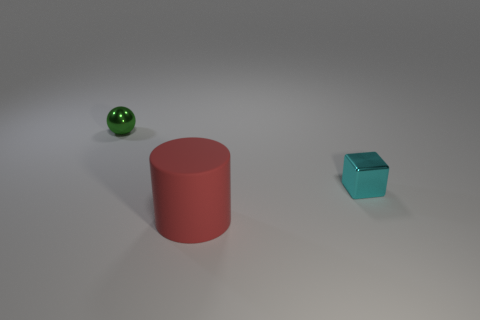Add 2 tiny green spheres. How many objects exist? 5 Subtract all cylinders. How many objects are left? 2 Subtract 1 red cylinders. How many objects are left? 2 Subtract all green rubber cubes. Subtract all small green shiny things. How many objects are left? 2 Add 2 green metal balls. How many green metal balls are left? 3 Add 2 green shiny balls. How many green shiny balls exist? 3 